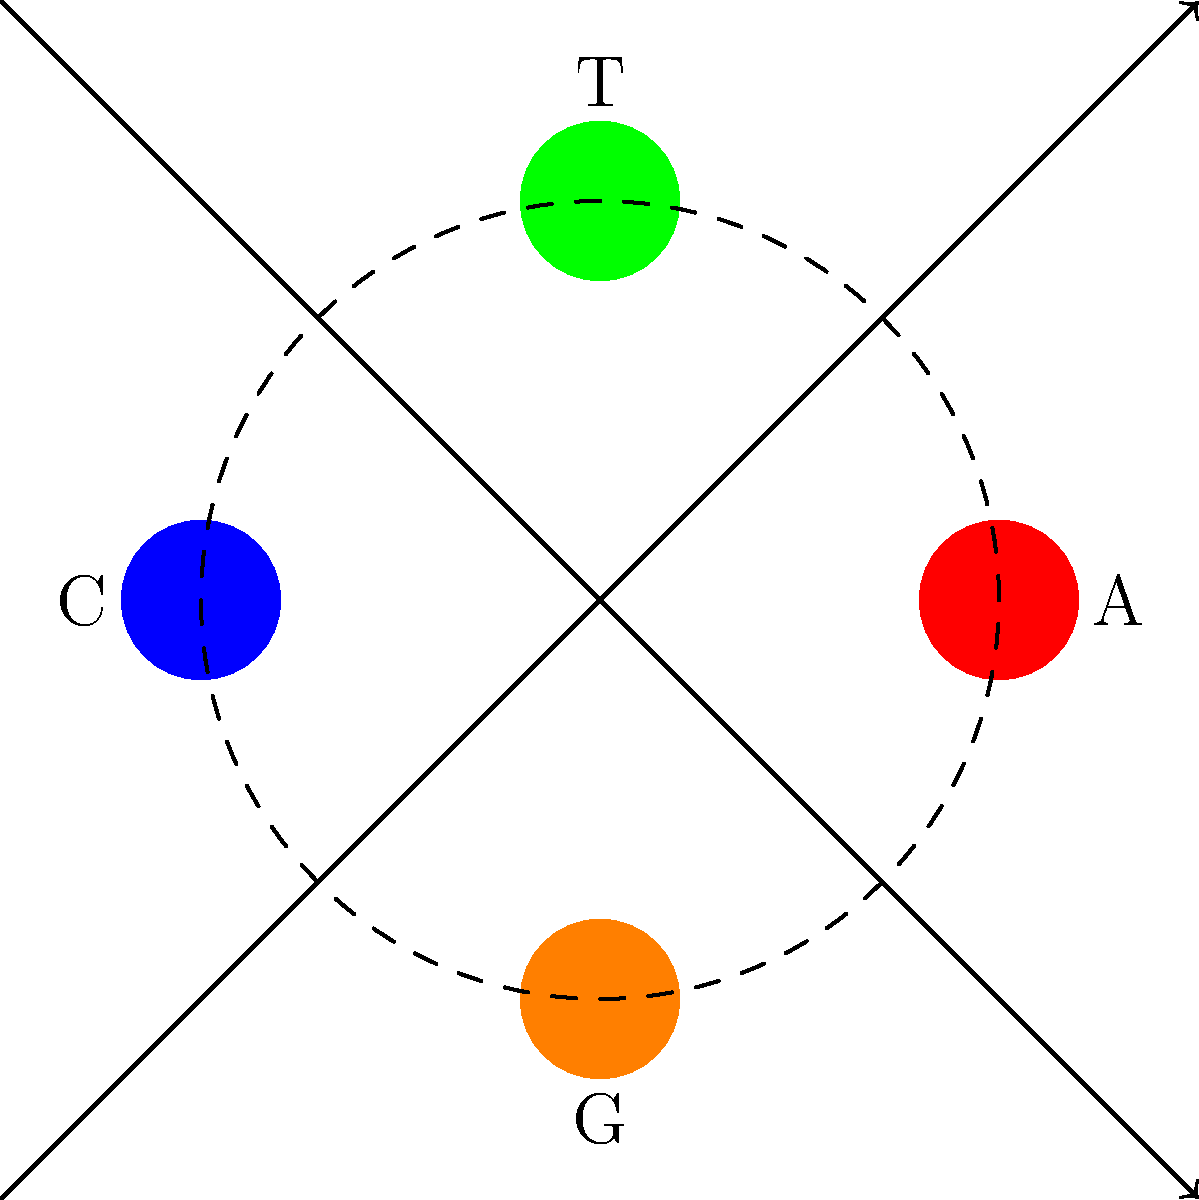In a novel exploring the ethical implications of genetic engineering, the author describes a chromosome with a unique gene sequence. The sequence consists of four nucleotides: Adenine (A), Thymine (T), Cytosine (C), and Guanine (G), arranged in a circular pattern. The permutation group of this gene sequence allows for rotations and reflections. How many distinct arrangements of this gene sequence are possible, considering all permutations that result in unique configurations? To solve this problem, we need to consider the symmetries of the circular arrangement:

1. The gene sequence can be rotated, giving 4 possible rotations (including the original position).

2. The sequence can also be reflected across any diameter, which doubles the number of possibilities.

3. However, we need to account for cases where reflection produces the same arrangement as rotation.

4. The total number of distinct arrangements is given by the order of the dihedral group $D_4$.

5. The order of $D_4$ is given by the formula: $|D_4| = 2n$, where $n$ is the number of vertices (in this case, 4).

6. Therefore, the number of distinct arrangements is:

   $|D_4| = 2 \cdot 4 = 8$

This result reflects all unique configurations of the gene sequence, accounting for rotations and reflections while avoiding double-counting.
Answer: 8 